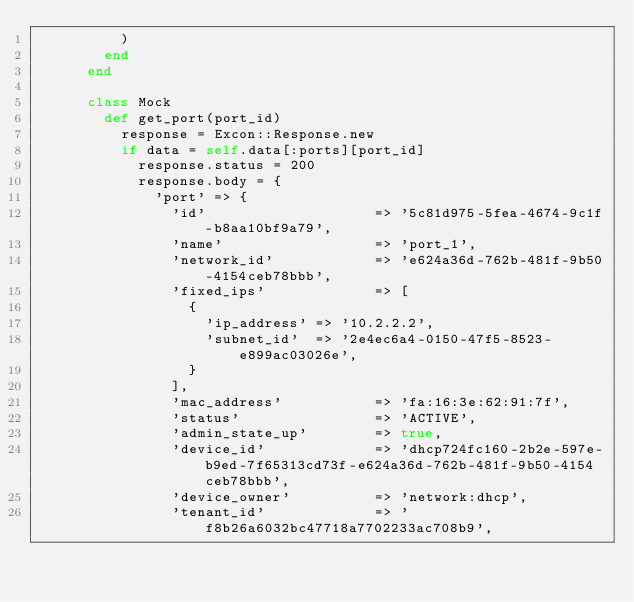Convert code to text. <code><loc_0><loc_0><loc_500><loc_500><_Ruby_>          )
        end
      end

      class Mock
        def get_port(port_id)
          response = Excon::Response.new
          if data = self.data[:ports][port_id]
            response.status = 200
            response.body = {
              'port' => {
                'id'                    => '5c81d975-5fea-4674-9c1f-b8aa10bf9a79',
                'name'                  => 'port_1',
                'network_id'            => 'e624a36d-762b-481f-9b50-4154ceb78bbb',
                'fixed_ips'             => [
                  {
                    'ip_address' => '10.2.2.2',
                    'subnet_id'  => '2e4ec6a4-0150-47f5-8523-e899ac03026e',
                  }
                ],
                'mac_address'           => 'fa:16:3e:62:91:7f',
                'status'                => 'ACTIVE',
                'admin_state_up'        => true,
                'device_id'             => 'dhcp724fc160-2b2e-597e-b9ed-7f65313cd73f-e624a36d-762b-481f-9b50-4154ceb78bbb',
                'device_owner'          => 'network:dhcp',
                'tenant_id'             => 'f8b26a6032bc47718a7702233ac708b9',</code> 